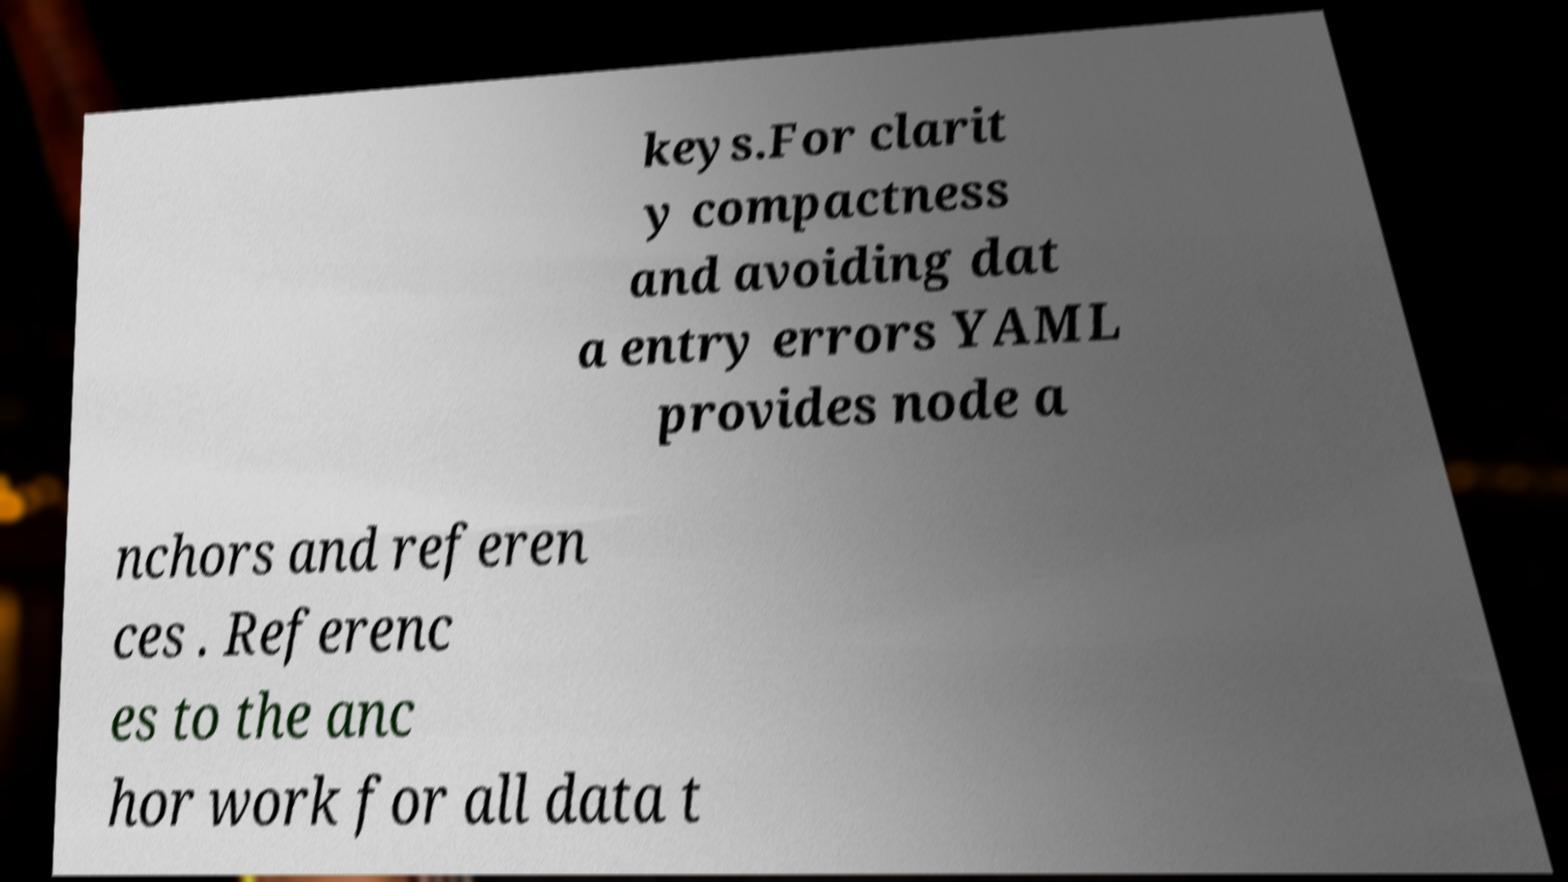What messages or text are displayed in this image? I need them in a readable, typed format. keys.For clarit y compactness and avoiding dat a entry errors YAML provides node a nchors and referen ces . Referenc es to the anc hor work for all data t 